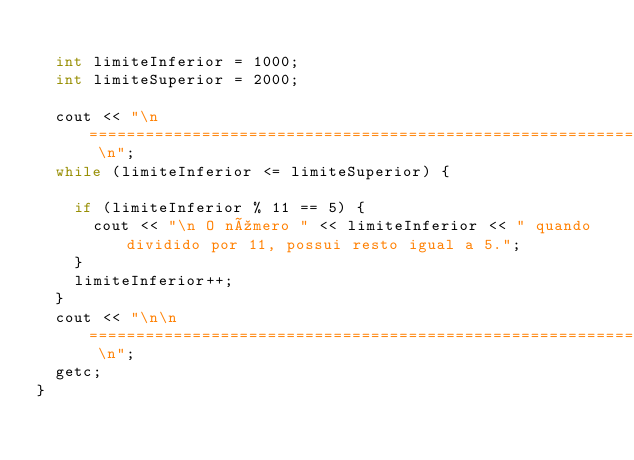<code> <loc_0><loc_0><loc_500><loc_500><_C++_>
	int limiteInferior = 1000;
	int limiteSuperior = 2000;

	cout << "\n ====================================================================== \n";
	while (limiteInferior <= limiteSuperior) {

		if (limiteInferior % 11 == 5) {
			cout << "\n O número " << limiteInferior << " quando dividido por 11, possui resto igual a 5.";
		}
		limiteInferior++;
	}
	cout << "\n\n ====================================================================== \n";
	getc;
}</code> 